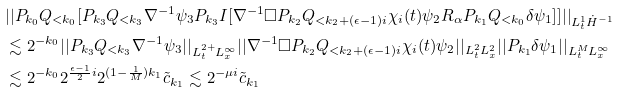<formula> <loc_0><loc_0><loc_500><loc_500>& | | P _ { k _ { 0 } } Q _ { < k _ { 0 } } [ P _ { k _ { 3 } } Q _ { < k _ { 3 } } \nabla ^ { - 1 } \psi _ { 3 } P _ { k _ { 3 } } I [ \nabla ^ { - 1 } \Box P _ { k _ { 2 } } Q _ { < k _ { 2 } + ( \epsilon - 1 ) i } \chi _ { i } ( t ) \psi _ { 2 } R _ { \alpha } P _ { k _ { 1 } } Q _ { < k _ { 0 } } \delta \psi _ { 1 } ] ] | | _ { L _ { t } ^ { 1 } \dot { H } ^ { - 1 } } \\ & \lesssim 2 ^ { - k _ { 0 } } | | P _ { k _ { 3 } } Q _ { < k _ { 3 } } \nabla ^ { - 1 } \psi _ { 3 } | | _ { L _ { t } ^ { 2 + } L _ { x } ^ { \infty } } | | \nabla ^ { - 1 } \Box P _ { k _ { 2 } } Q _ { < k _ { 2 } + ( \epsilon - 1 ) i } \chi _ { i } ( t ) \psi _ { 2 } | | _ { L _ { t } ^ { 2 } L _ { x } ^ { 2 } } | | P _ { k _ { 1 } } \delta \psi _ { 1 } | | _ { L _ { t } ^ { M } L _ { x } ^ { \infty } } \\ & \lesssim 2 ^ { - k _ { 0 } } 2 ^ { \frac { \epsilon - 1 } { 2 } i } 2 ^ { ( 1 - \frac { 1 } { M } ) k _ { 1 } } \tilde { c } _ { k _ { 1 } } \lesssim 2 ^ { - \mu i } \tilde { c } _ { k _ { 1 } } \\</formula> 